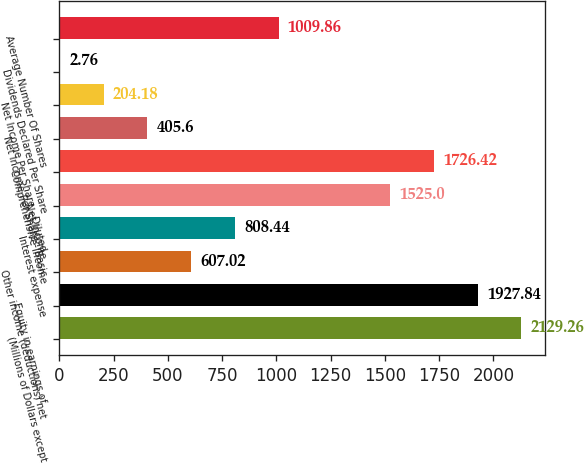Convert chart to OTSL. <chart><loc_0><loc_0><loc_500><loc_500><bar_chart><fcel>(Millions of Dollars except<fcel>Equity in earnings of<fcel>Other income (deductions) net<fcel>Interest expense<fcel>Net Income<fcel>Comprehensive Income<fcel>Net Income Per Share - Basic<fcel>Net Income Per Share - Diluted<fcel>Dividends Declared Per Share<fcel>Average Number Of Shares<nl><fcel>2129.26<fcel>1927.84<fcel>607.02<fcel>808.44<fcel>1525<fcel>1726.42<fcel>405.6<fcel>204.18<fcel>2.76<fcel>1009.86<nl></chart> 